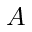<formula> <loc_0><loc_0><loc_500><loc_500>A</formula> 